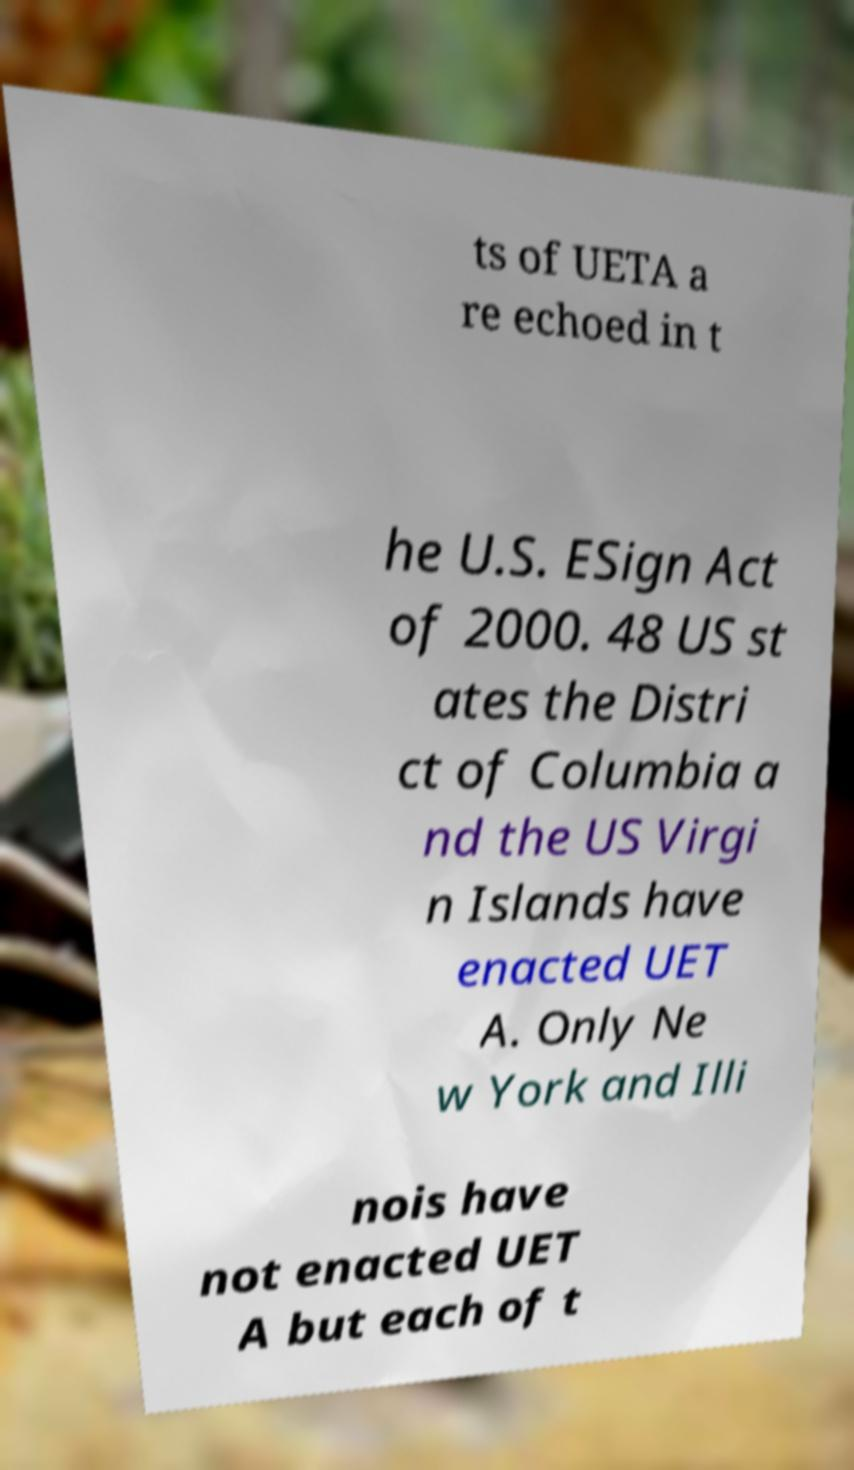I need the written content from this picture converted into text. Can you do that? ts of UETA a re echoed in t he U.S. ESign Act of 2000. 48 US st ates the Distri ct of Columbia a nd the US Virgi n Islands have enacted UET A. Only Ne w York and Illi nois have not enacted UET A but each of t 